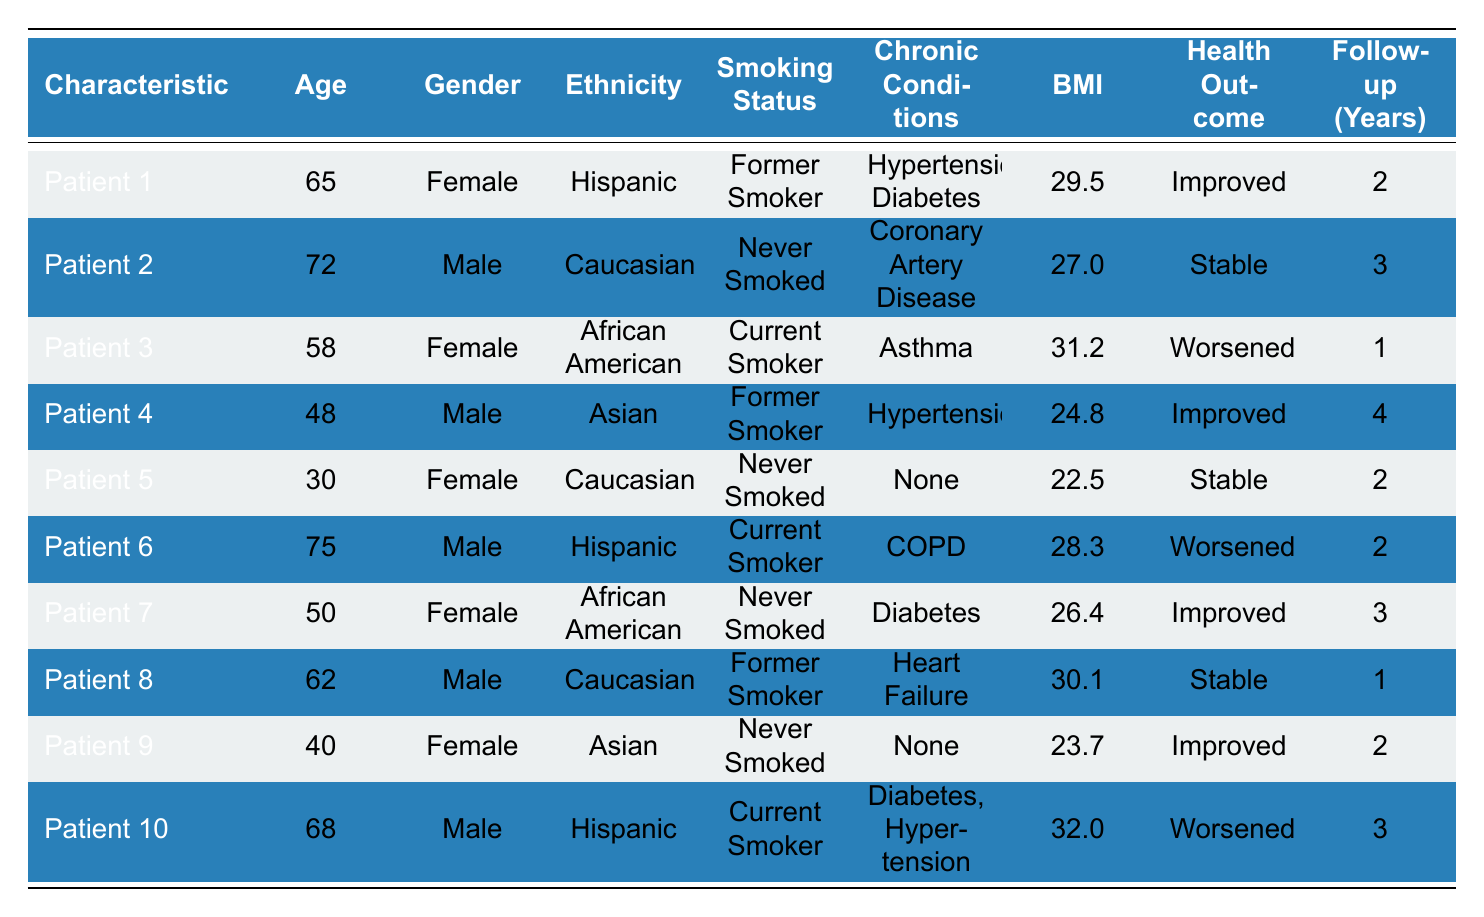What is the health outcome of Patient 5? Patient 5 is in the "Stable" category for health outcome, as indicated in the table.
Answer: Stable How many patients are current smokers? There are three patients (Patient 3, Patient 6, and Patient 10) listed as current smokers in the table.
Answer: 3 What is the age of Patient 2? The age of Patient 2 is 72, as shown in the table under the age column.
Answer: 72 Which patient has the highest body mass index (BMI)? Patient 10 has the highest BMI at 32.0, which can be derived by comparing the BMI values of all patients listed.
Answer: Patient 10 What percentage of patients had their health outcomes improved? Three out of ten patients had improved outcomes, which is (3/10)*100 = 30%.
Answer: 30% Is there any patient with no chronic conditions? Yes, Patients 5 and 9 reported having no chronic conditions. This can be verified by checking the chronic conditions column.
Answer: Yes Are there more female patients with worsened health outcomes or male patients with worsened health outcomes? There are two females (Patients 3 and 7) and two males (Patients 6 and 10) with worsened outcomes, giving a total of two for each gender.
Answer: Equal What is the average age of patients who improved their health? The average age of Patients 1, 4, 7, and 9 is calculated as (65 + 48 + 50 + 40) / 4 = 50.75.
Answer: 50.75 How many patients have chronic conditions related to diabetes? Three patients (Patient 3, Patient 10, and Patient 7) have diabetes, based on the specified chronic conditions.
Answer: 3 Was there a patient aged 30 or less in this study? Yes, Patient 5 is 30 years old, which can be confirmed by checking the age column in the table.
Answer: Yes 